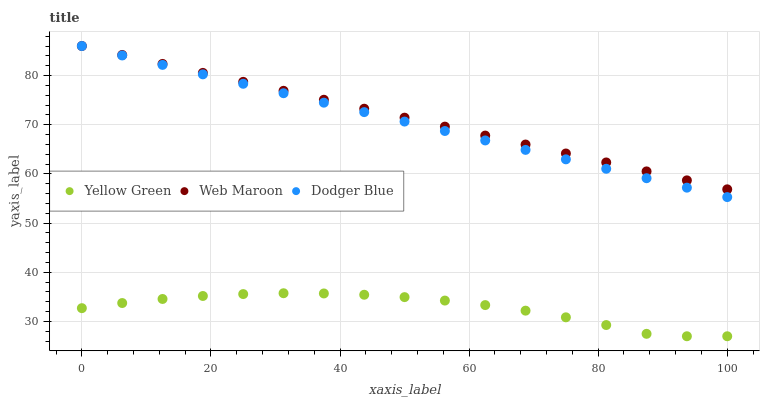Does Yellow Green have the minimum area under the curve?
Answer yes or no. Yes. Does Web Maroon have the maximum area under the curve?
Answer yes or no. Yes. Does Web Maroon have the minimum area under the curve?
Answer yes or no. No. Does Yellow Green have the maximum area under the curve?
Answer yes or no. No. Is Dodger Blue the smoothest?
Answer yes or no. Yes. Is Yellow Green the roughest?
Answer yes or no. Yes. Is Web Maroon the smoothest?
Answer yes or no. No. Is Web Maroon the roughest?
Answer yes or no. No. Does Yellow Green have the lowest value?
Answer yes or no. Yes. Does Web Maroon have the lowest value?
Answer yes or no. No. Does Web Maroon have the highest value?
Answer yes or no. Yes. Does Yellow Green have the highest value?
Answer yes or no. No. Is Yellow Green less than Web Maroon?
Answer yes or no. Yes. Is Web Maroon greater than Yellow Green?
Answer yes or no. Yes. Does Web Maroon intersect Dodger Blue?
Answer yes or no. Yes. Is Web Maroon less than Dodger Blue?
Answer yes or no. No. Is Web Maroon greater than Dodger Blue?
Answer yes or no. No. Does Yellow Green intersect Web Maroon?
Answer yes or no. No. 